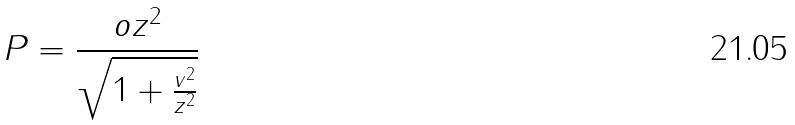<formula> <loc_0><loc_0><loc_500><loc_500>P = \frac { o z ^ { 2 } } { \sqrt { 1 + \frac { v ^ { 2 } } { z ^ { 2 } } } }</formula> 